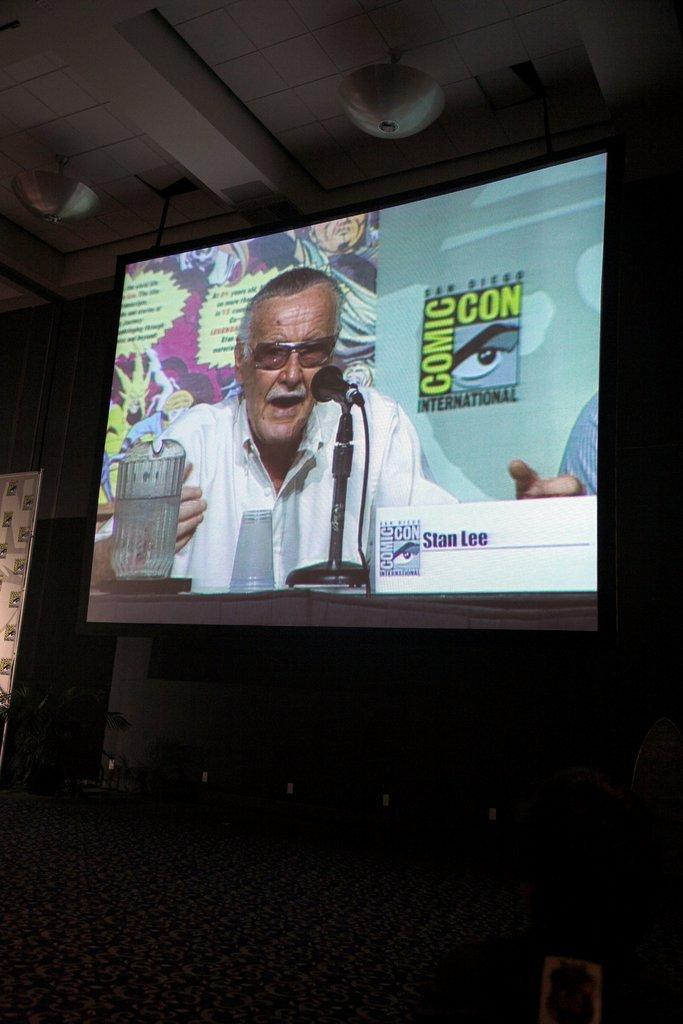<image>
Present a compact description of the photo's key features. The tv screen shows a man being interviewed at  comic con. 